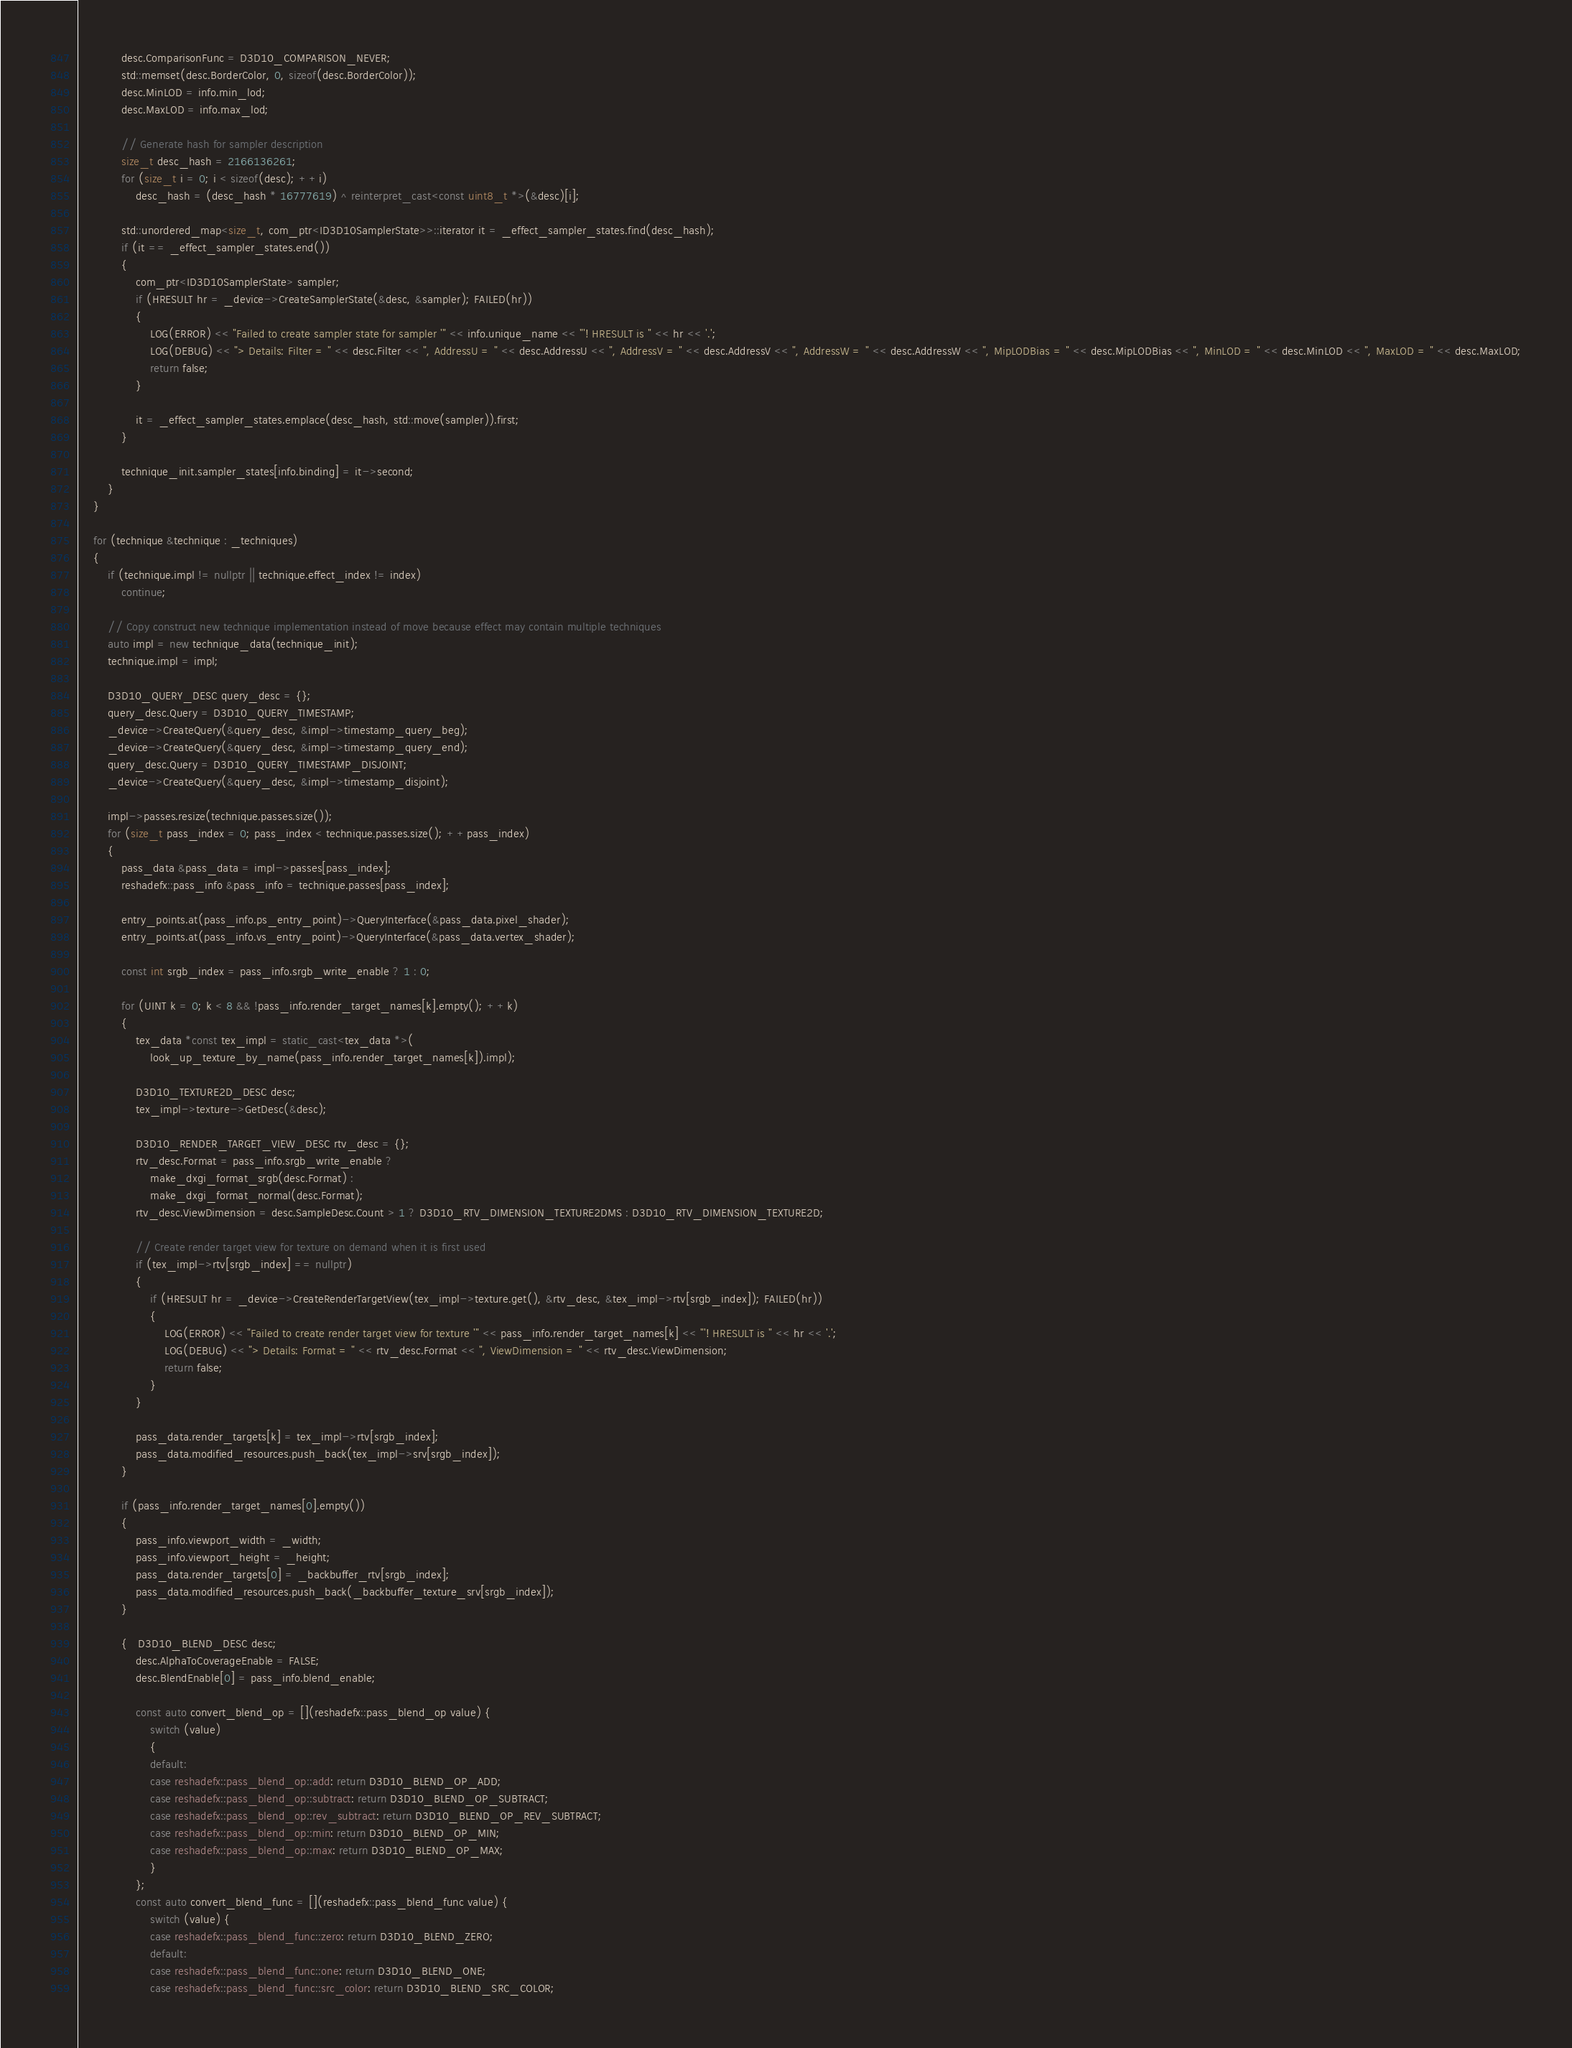Convert code to text. <code><loc_0><loc_0><loc_500><loc_500><_C++_>			desc.ComparisonFunc = D3D10_COMPARISON_NEVER;
			std::memset(desc.BorderColor, 0, sizeof(desc.BorderColor));
			desc.MinLOD = info.min_lod;
			desc.MaxLOD = info.max_lod;

			// Generate hash for sampler description
			size_t desc_hash = 2166136261;
			for (size_t i = 0; i < sizeof(desc); ++i)
				desc_hash = (desc_hash * 16777619) ^ reinterpret_cast<const uint8_t *>(&desc)[i];

			std::unordered_map<size_t, com_ptr<ID3D10SamplerState>>::iterator it = _effect_sampler_states.find(desc_hash);
			if (it == _effect_sampler_states.end())
			{
				com_ptr<ID3D10SamplerState> sampler;
				if (HRESULT hr = _device->CreateSamplerState(&desc, &sampler); FAILED(hr))
				{
					LOG(ERROR) << "Failed to create sampler state for sampler '" << info.unique_name << "'! HRESULT is " << hr << '.';
					LOG(DEBUG) << "> Details: Filter = " << desc.Filter << ", AddressU = " << desc.AddressU << ", AddressV = " << desc.AddressV << ", AddressW = " << desc.AddressW << ", MipLODBias = " << desc.MipLODBias << ", MinLOD = " << desc.MinLOD << ", MaxLOD = " << desc.MaxLOD;
					return false;
				}

				it = _effect_sampler_states.emplace(desc_hash, std::move(sampler)).first;
			}

			technique_init.sampler_states[info.binding] = it->second;
		}
	}

	for (technique &technique : _techniques)
	{
		if (technique.impl != nullptr || technique.effect_index != index)
			continue;

		// Copy construct new technique implementation instead of move because effect may contain multiple techniques
		auto impl = new technique_data(technique_init);
		technique.impl = impl;

		D3D10_QUERY_DESC query_desc = {};
		query_desc.Query = D3D10_QUERY_TIMESTAMP;
		_device->CreateQuery(&query_desc, &impl->timestamp_query_beg);
		_device->CreateQuery(&query_desc, &impl->timestamp_query_end);
		query_desc.Query = D3D10_QUERY_TIMESTAMP_DISJOINT;
		_device->CreateQuery(&query_desc, &impl->timestamp_disjoint);

		impl->passes.resize(technique.passes.size());
		for (size_t pass_index = 0; pass_index < technique.passes.size(); ++pass_index)
		{
			pass_data &pass_data = impl->passes[pass_index];
			reshadefx::pass_info &pass_info = technique.passes[pass_index];

			entry_points.at(pass_info.ps_entry_point)->QueryInterface(&pass_data.pixel_shader);
			entry_points.at(pass_info.vs_entry_point)->QueryInterface(&pass_data.vertex_shader);

			const int srgb_index = pass_info.srgb_write_enable ? 1 : 0;

			for (UINT k = 0; k < 8 && !pass_info.render_target_names[k].empty(); ++k)
			{
				tex_data *const tex_impl = static_cast<tex_data *>(
					look_up_texture_by_name(pass_info.render_target_names[k]).impl);

				D3D10_TEXTURE2D_DESC desc;
				tex_impl->texture->GetDesc(&desc);

				D3D10_RENDER_TARGET_VIEW_DESC rtv_desc = {};
				rtv_desc.Format = pass_info.srgb_write_enable ?
					make_dxgi_format_srgb(desc.Format) :
					make_dxgi_format_normal(desc.Format);
				rtv_desc.ViewDimension = desc.SampleDesc.Count > 1 ? D3D10_RTV_DIMENSION_TEXTURE2DMS : D3D10_RTV_DIMENSION_TEXTURE2D;

				// Create render target view for texture on demand when it is first used
				if (tex_impl->rtv[srgb_index] == nullptr)
				{
					if (HRESULT hr = _device->CreateRenderTargetView(tex_impl->texture.get(), &rtv_desc, &tex_impl->rtv[srgb_index]); FAILED(hr))
					{
						LOG(ERROR) << "Failed to create render target view for texture '" << pass_info.render_target_names[k] << "'! HRESULT is " << hr << '.';
						LOG(DEBUG) << "> Details: Format = " << rtv_desc.Format << ", ViewDimension = " << rtv_desc.ViewDimension;
						return false;
					}
				}

				pass_data.render_targets[k] = tex_impl->rtv[srgb_index];
				pass_data.modified_resources.push_back(tex_impl->srv[srgb_index]);
			}

			if (pass_info.render_target_names[0].empty())
			{
				pass_info.viewport_width = _width;
				pass_info.viewport_height = _height;
				pass_data.render_targets[0] = _backbuffer_rtv[srgb_index];
				pass_data.modified_resources.push_back(_backbuffer_texture_srv[srgb_index]);
			}

			{   D3D10_BLEND_DESC desc;
				desc.AlphaToCoverageEnable = FALSE;
				desc.BlendEnable[0] = pass_info.blend_enable;

				const auto convert_blend_op = [](reshadefx::pass_blend_op value) {
					switch (value)
					{
					default:
					case reshadefx::pass_blend_op::add: return D3D10_BLEND_OP_ADD;
					case reshadefx::pass_blend_op::subtract: return D3D10_BLEND_OP_SUBTRACT;
					case reshadefx::pass_blend_op::rev_subtract: return D3D10_BLEND_OP_REV_SUBTRACT;
					case reshadefx::pass_blend_op::min: return D3D10_BLEND_OP_MIN;
					case reshadefx::pass_blend_op::max: return D3D10_BLEND_OP_MAX;
					}
				};
				const auto convert_blend_func = [](reshadefx::pass_blend_func value) {
					switch (value) {
					case reshadefx::pass_blend_func::zero: return D3D10_BLEND_ZERO;
					default:
					case reshadefx::pass_blend_func::one: return D3D10_BLEND_ONE;
					case reshadefx::pass_blend_func::src_color: return D3D10_BLEND_SRC_COLOR;</code> 